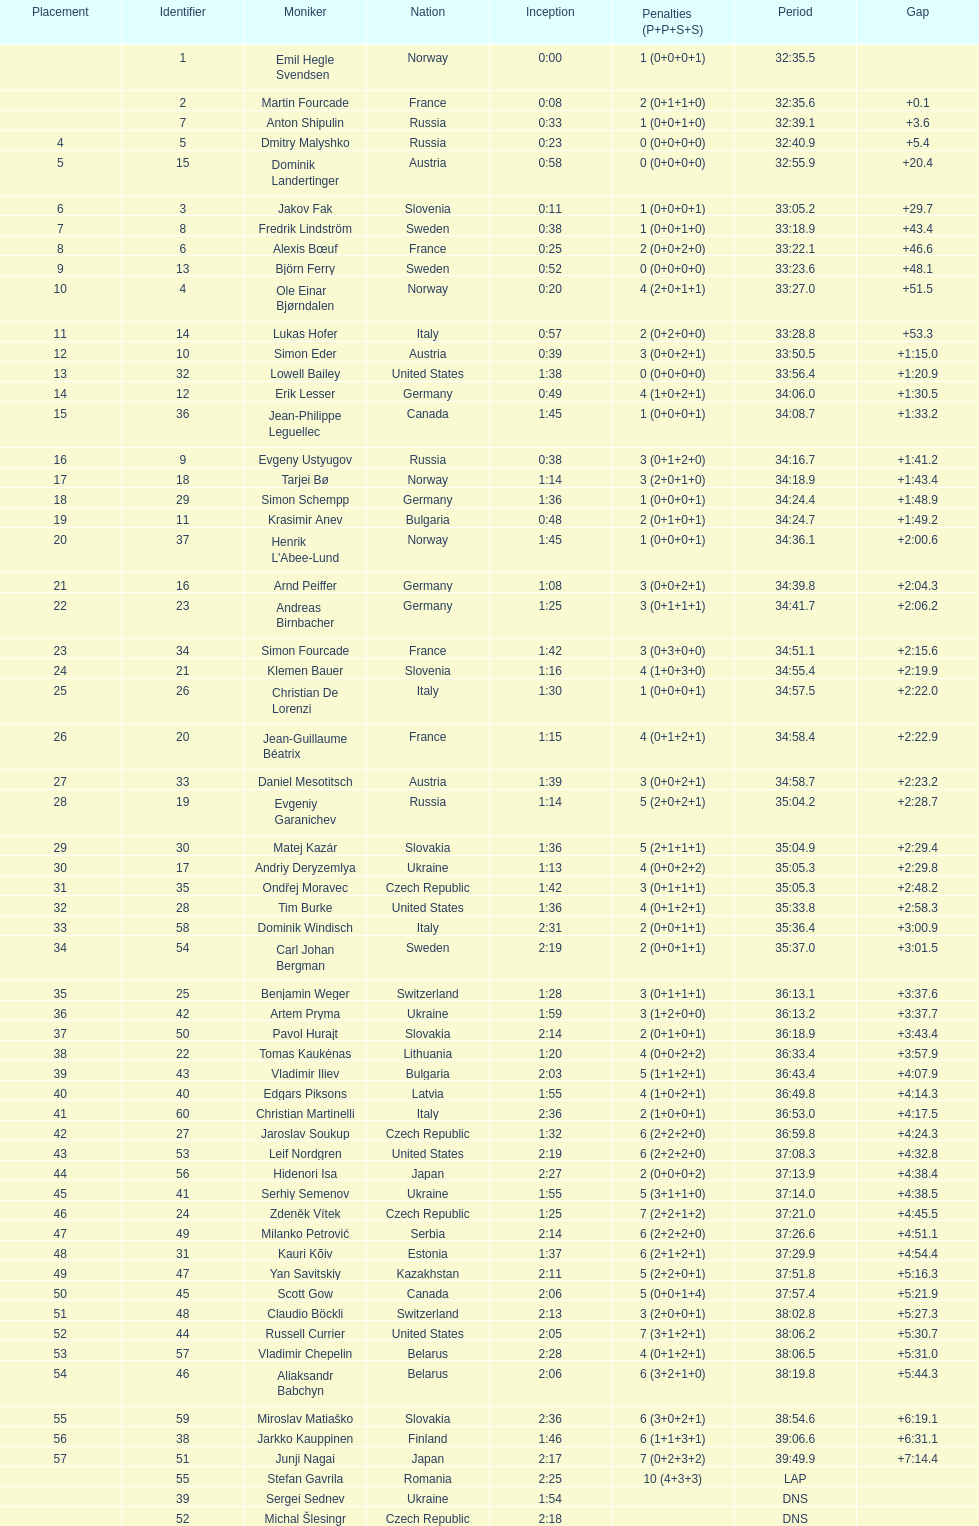What is the number of russian participants? 4. Parse the table in full. {'header': ['Placement', 'Identifier', 'Moniker', 'Nation', 'Inception', 'Penalties (P+P+S+S)', 'Period', 'Gap'], 'rows': [['', '1', 'Emil Hegle Svendsen', 'Norway', '0:00', '1 (0+0+0+1)', '32:35.5', ''], ['', '2', 'Martin Fourcade', 'France', '0:08', '2 (0+1+1+0)', '32:35.6', '+0.1'], ['', '7', 'Anton Shipulin', 'Russia', '0:33', '1 (0+0+1+0)', '32:39.1', '+3.6'], ['4', '5', 'Dmitry Malyshko', 'Russia', '0:23', '0 (0+0+0+0)', '32:40.9', '+5.4'], ['5', '15', 'Dominik Landertinger', 'Austria', '0:58', '0 (0+0+0+0)', '32:55.9', '+20.4'], ['6', '3', 'Jakov Fak', 'Slovenia', '0:11', '1 (0+0+0+1)', '33:05.2', '+29.7'], ['7', '8', 'Fredrik Lindström', 'Sweden', '0:38', '1 (0+0+1+0)', '33:18.9', '+43.4'], ['8', '6', 'Alexis Bœuf', 'France', '0:25', '2 (0+0+2+0)', '33:22.1', '+46.6'], ['9', '13', 'Björn Ferry', 'Sweden', '0:52', '0 (0+0+0+0)', '33:23.6', '+48.1'], ['10', '4', 'Ole Einar Bjørndalen', 'Norway', '0:20', '4 (2+0+1+1)', '33:27.0', '+51.5'], ['11', '14', 'Lukas Hofer', 'Italy', '0:57', '2 (0+2+0+0)', '33:28.8', '+53.3'], ['12', '10', 'Simon Eder', 'Austria', '0:39', '3 (0+0+2+1)', '33:50.5', '+1:15.0'], ['13', '32', 'Lowell Bailey', 'United States', '1:38', '0 (0+0+0+0)', '33:56.4', '+1:20.9'], ['14', '12', 'Erik Lesser', 'Germany', '0:49', '4 (1+0+2+1)', '34:06.0', '+1:30.5'], ['15', '36', 'Jean-Philippe Leguellec', 'Canada', '1:45', '1 (0+0+0+1)', '34:08.7', '+1:33.2'], ['16', '9', 'Evgeny Ustyugov', 'Russia', '0:38', '3 (0+1+2+0)', '34:16.7', '+1:41.2'], ['17', '18', 'Tarjei Bø', 'Norway', '1:14', '3 (2+0+1+0)', '34:18.9', '+1:43.4'], ['18', '29', 'Simon Schempp', 'Germany', '1:36', '1 (0+0+0+1)', '34:24.4', '+1:48.9'], ['19', '11', 'Krasimir Anev', 'Bulgaria', '0:48', '2 (0+1+0+1)', '34:24.7', '+1:49.2'], ['20', '37', "Henrik L'Abee-Lund", 'Norway', '1:45', '1 (0+0+0+1)', '34:36.1', '+2:00.6'], ['21', '16', 'Arnd Peiffer', 'Germany', '1:08', '3 (0+0+2+1)', '34:39.8', '+2:04.3'], ['22', '23', 'Andreas Birnbacher', 'Germany', '1:25', '3 (0+1+1+1)', '34:41.7', '+2:06.2'], ['23', '34', 'Simon Fourcade', 'France', '1:42', '3 (0+3+0+0)', '34:51.1', '+2:15.6'], ['24', '21', 'Klemen Bauer', 'Slovenia', '1:16', '4 (1+0+3+0)', '34:55.4', '+2:19.9'], ['25', '26', 'Christian De Lorenzi', 'Italy', '1:30', '1 (0+0+0+1)', '34:57.5', '+2:22.0'], ['26', '20', 'Jean-Guillaume Béatrix', 'France', '1:15', '4 (0+1+2+1)', '34:58.4', '+2:22.9'], ['27', '33', 'Daniel Mesotitsch', 'Austria', '1:39', '3 (0+0+2+1)', '34:58.7', '+2:23.2'], ['28', '19', 'Evgeniy Garanichev', 'Russia', '1:14', '5 (2+0+2+1)', '35:04.2', '+2:28.7'], ['29', '30', 'Matej Kazár', 'Slovakia', '1:36', '5 (2+1+1+1)', '35:04.9', '+2:29.4'], ['30', '17', 'Andriy Deryzemlya', 'Ukraine', '1:13', '4 (0+0+2+2)', '35:05.3', '+2:29.8'], ['31', '35', 'Ondřej Moravec', 'Czech Republic', '1:42', '3 (0+1+1+1)', '35:05.3', '+2:48.2'], ['32', '28', 'Tim Burke', 'United States', '1:36', '4 (0+1+2+1)', '35:33.8', '+2:58.3'], ['33', '58', 'Dominik Windisch', 'Italy', '2:31', '2 (0+0+1+1)', '35:36.4', '+3:00.9'], ['34', '54', 'Carl Johan Bergman', 'Sweden', '2:19', '2 (0+0+1+1)', '35:37.0', '+3:01.5'], ['35', '25', 'Benjamin Weger', 'Switzerland', '1:28', '3 (0+1+1+1)', '36:13.1', '+3:37.6'], ['36', '42', 'Artem Pryma', 'Ukraine', '1:59', '3 (1+2+0+0)', '36:13.2', '+3:37.7'], ['37', '50', 'Pavol Hurajt', 'Slovakia', '2:14', '2 (0+1+0+1)', '36:18.9', '+3:43.4'], ['38', '22', 'Tomas Kaukėnas', 'Lithuania', '1:20', '4 (0+0+2+2)', '36:33.4', '+3:57.9'], ['39', '43', 'Vladimir Iliev', 'Bulgaria', '2:03', '5 (1+1+2+1)', '36:43.4', '+4:07.9'], ['40', '40', 'Edgars Piksons', 'Latvia', '1:55', '4 (1+0+2+1)', '36:49.8', '+4:14.3'], ['41', '60', 'Christian Martinelli', 'Italy', '2:36', '2 (1+0+0+1)', '36:53.0', '+4:17.5'], ['42', '27', 'Jaroslav Soukup', 'Czech Republic', '1:32', '6 (2+2+2+0)', '36:59.8', '+4:24.3'], ['43', '53', 'Leif Nordgren', 'United States', '2:19', '6 (2+2+2+0)', '37:08.3', '+4:32.8'], ['44', '56', 'Hidenori Isa', 'Japan', '2:27', '2 (0+0+0+2)', '37:13.9', '+4:38.4'], ['45', '41', 'Serhiy Semenov', 'Ukraine', '1:55', '5 (3+1+1+0)', '37:14.0', '+4:38.5'], ['46', '24', 'Zdeněk Vítek', 'Czech Republic', '1:25', '7 (2+2+1+2)', '37:21.0', '+4:45.5'], ['47', '49', 'Milanko Petrović', 'Serbia', '2:14', '6 (2+2+2+0)', '37:26.6', '+4:51.1'], ['48', '31', 'Kauri Kõiv', 'Estonia', '1:37', '6 (2+1+2+1)', '37:29.9', '+4:54.4'], ['49', '47', 'Yan Savitskiy', 'Kazakhstan', '2:11', '5 (2+2+0+1)', '37:51.8', '+5:16.3'], ['50', '45', 'Scott Gow', 'Canada', '2:06', '5 (0+0+1+4)', '37:57.4', '+5:21.9'], ['51', '48', 'Claudio Böckli', 'Switzerland', '2:13', '3 (2+0+0+1)', '38:02.8', '+5:27.3'], ['52', '44', 'Russell Currier', 'United States', '2:05', '7 (3+1+2+1)', '38:06.2', '+5:30.7'], ['53', '57', 'Vladimir Chepelin', 'Belarus', '2:28', '4 (0+1+2+1)', '38:06.5', '+5:31.0'], ['54', '46', 'Aliaksandr Babchyn', 'Belarus', '2:06', '6 (3+2+1+0)', '38:19.8', '+5:44.3'], ['55', '59', 'Miroslav Matiaško', 'Slovakia', '2:36', '6 (3+0+2+1)', '38:54.6', '+6:19.1'], ['56', '38', 'Jarkko Kauppinen', 'Finland', '1:46', '6 (1+1+3+1)', '39:06.6', '+6:31.1'], ['57', '51', 'Junji Nagai', 'Japan', '2:17', '7 (0+2+3+2)', '39:49.9', '+7:14.4'], ['', '55', 'Stefan Gavrila', 'Romania', '2:25', '10 (4+3+3)', 'LAP', ''], ['', '39', 'Sergei Sednev', 'Ukraine', '1:54', '', 'DNS', ''], ['', '52', 'Michal Šlesingr', 'Czech Republic', '2:18', '', 'DNS', '']]} 